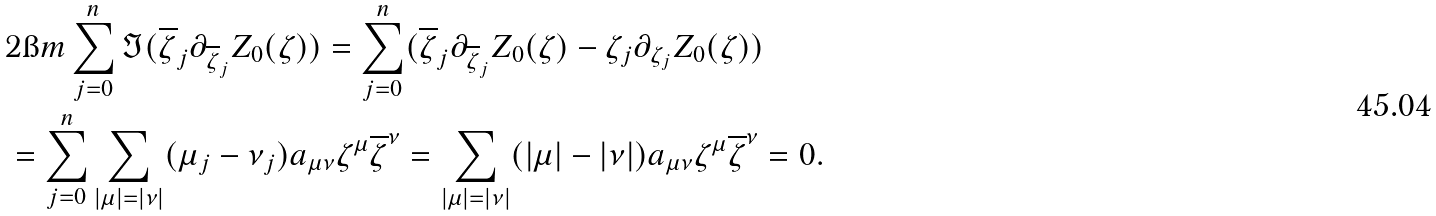Convert formula to latex. <formula><loc_0><loc_0><loc_500><loc_500>& 2 \i m \sum _ { j = 0 } ^ { n } \Im ( \overline { \zeta } _ { j } \partial _ { \overline { \zeta } _ { j } } Z _ { 0 } ( \zeta ) ) = \sum _ { j = 0 } ^ { n } ( \overline { \zeta } _ { j } \partial _ { \overline { \zeta } _ { j } } Z _ { 0 } ( \zeta ) - { \zeta } _ { j } \partial _ { { \zeta } _ { j } } Z _ { 0 } ( \zeta ) ) \\ & = \sum _ { j = 0 } ^ { n } \sum _ { | \mu | = | \nu | } ( \mu _ { j } - \nu _ { j } ) a _ { \mu \nu } \zeta ^ { \mu } \overline { \zeta } ^ { \nu } = \sum _ { | \mu | = | \nu | } ( | \mu | - | \nu | ) a _ { \mu \nu } \zeta ^ { \mu } \overline { \zeta } ^ { \nu } = 0 .</formula> 